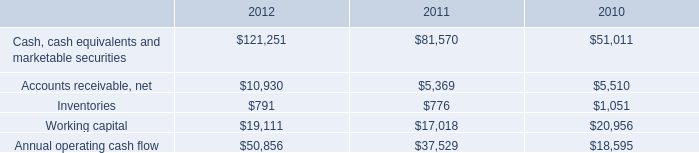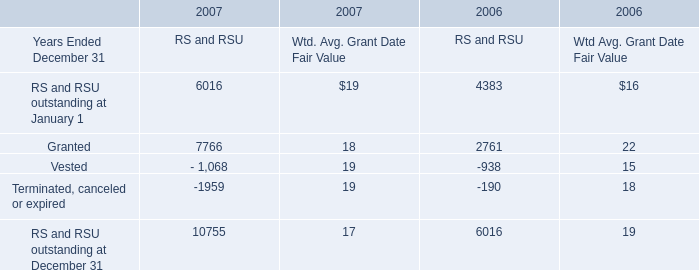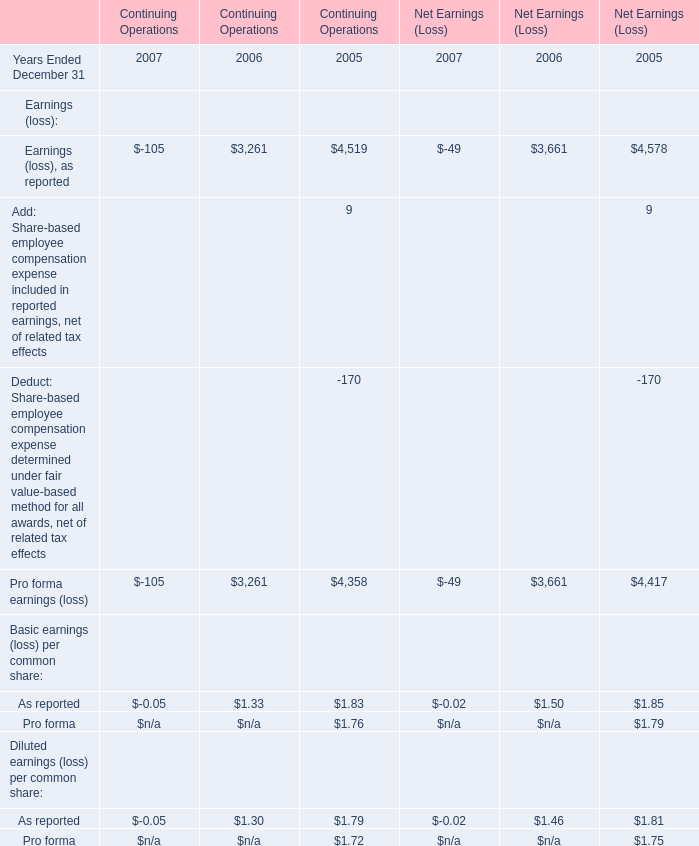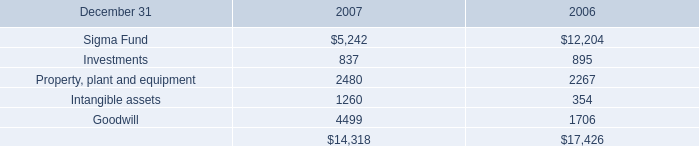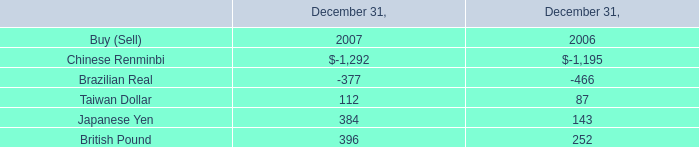What is the sum of the Pro forma earnings (loss) in the years where Earnings (loss), as reported is positive? 
Computations: (((3261 + 4358) + 3661) + 4417)
Answer: 15697.0. 